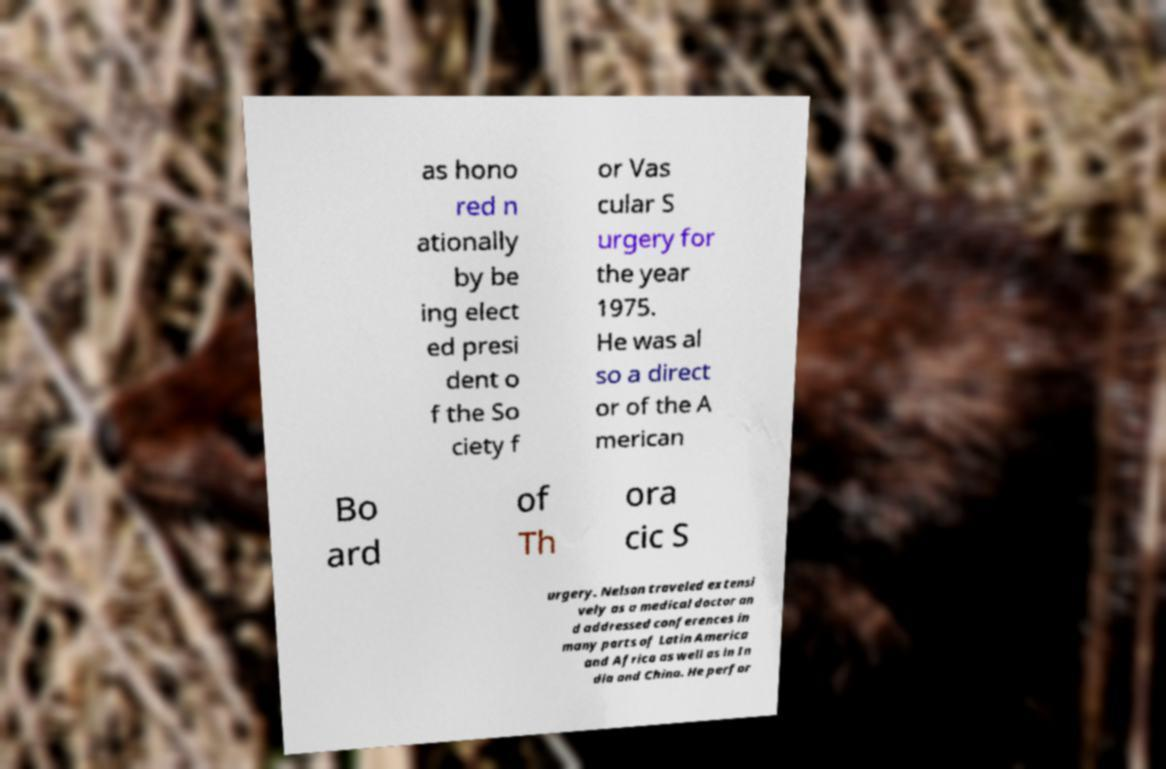Can you accurately transcribe the text from the provided image for me? as hono red n ationally by be ing elect ed presi dent o f the So ciety f or Vas cular S urgery for the year 1975. He was al so a direct or of the A merican Bo ard of Th ora cic S urgery. Nelson traveled extensi vely as a medical doctor an d addressed conferences in many parts of Latin America and Africa as well as in In dia and China. He perfor 